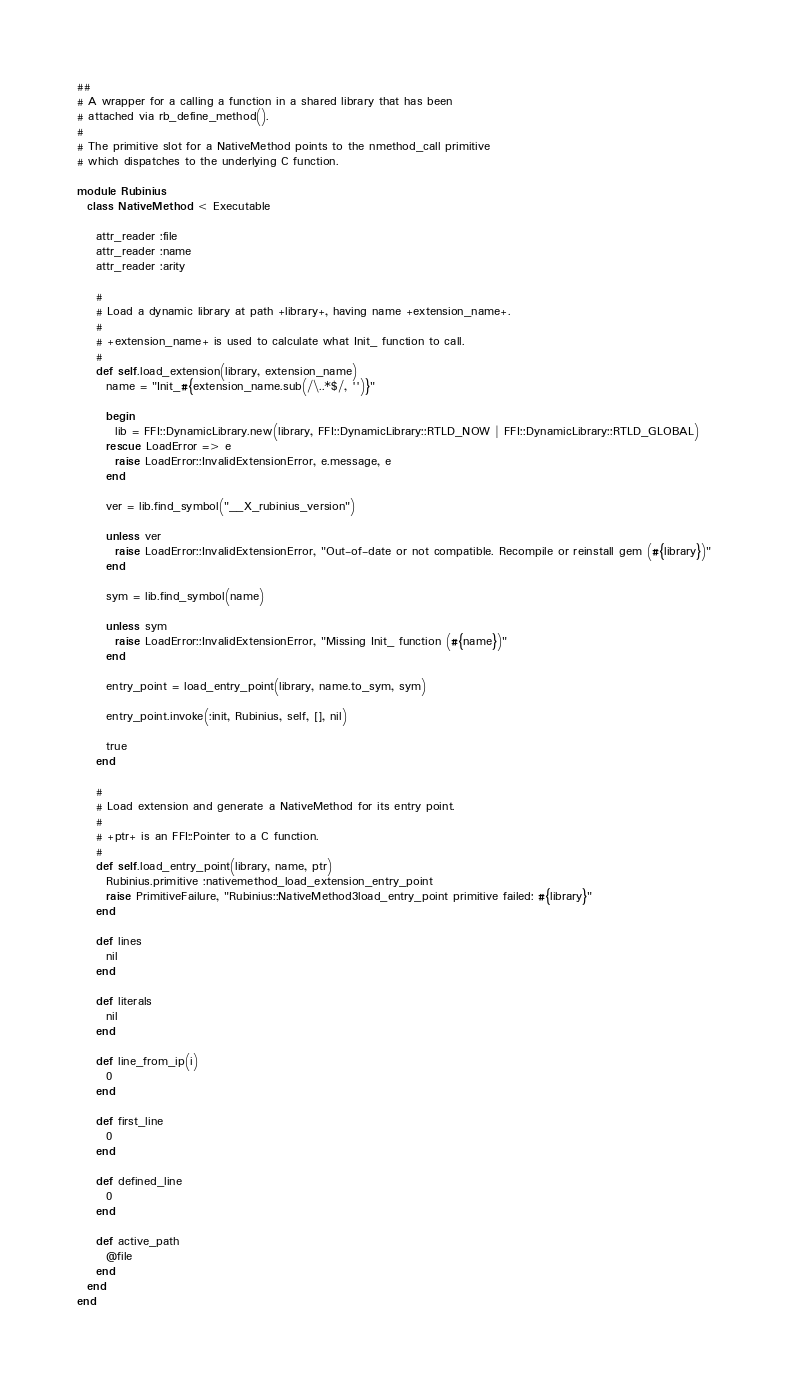<code> <loc_0><loc_0><loc_500><loc_500><_Ruby_>##
# A wrapper for a calling a function in a shared library that has been
# attached via rb_define_method().
#
# The primitive slot for a NativeMethod points to the nmethod_call primitive
# which dispatches to the underlying C function.

module Rubinius
  class NativeMethod < Executable

    attr_reader :file
    attr_reader :name
    attr_reader :arity

    #
    # Load a dynamic library at path +library+, having name +extension_name+.
    #
    # +extension_name+ is used to calculate what Init_ function to call.
    #
    def self.load_extension(library, extension_name)
      name = "Init_#{extension_name.sub(/\..*$/, '')}"

      begin
        lib = FFI::DynamicLibrary.new(library, FFI::DynamicLibrary::RTLD_NOW | FFI::DynamicLibrary::RTLD_GLOBAL)
      rescue LoadError => e
        raise LoadError::InvalidExtensionError, e.message, e
      end

      ver = lib.find_symbol("__X_rubinius_version")

      unless ver
        raise LoadError::InvalidExtensionError, "Out-of-date or not compatible. Recompile or reinstall gem (#{library})"
      end

      sym = lib.find_symbol(name)

      unless sym
        raise LoadError::InvalidExtensionError, "Missing Init_ function (#{name})"
      end

      entry_point = load_entry_point(library, name.to_sym, sym)

      entry_point.invoke(:init, Rubinius, self, [], nil)

      true
    end

    #
    # Load extension and generate a NativeMethod for its entry point.
    #
    # +ptr+ is an FFI::Pointer to a C function.
    #
    def self.load_entry_point(library, name, ptr)
      Rubinius.primitive :nativemethod_load_extension_entry_point
      raise PrimitiveFailure, "Rubinius::NativeMethod3load_entry_point primitive failed: #{library}"
    end

    def lines
      nil
    end

    def literals
      nil
    end

    def line_from_ip(i)
      0
    end

    def first_line
      0
    end

    def defined_line
      0
    end

    def active_path
      @file
    end
  end
end
</code> 